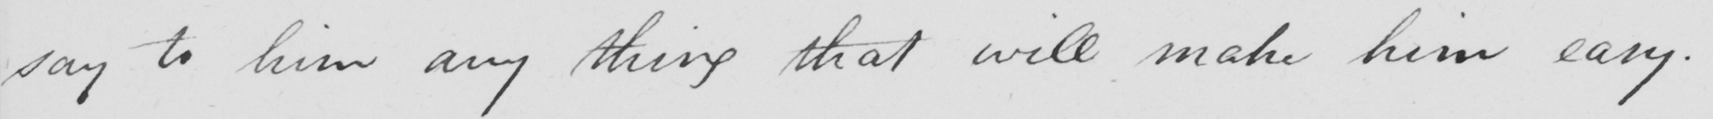Please provide the text content of this handwritten line. say to him any thing that will make him easy. 